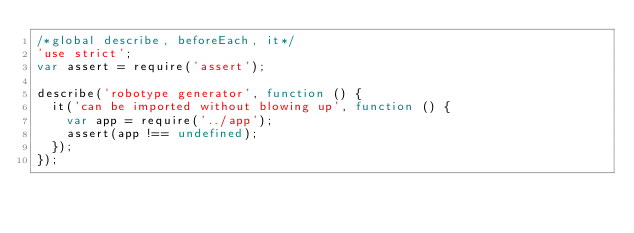Convert code to text. <code><loc_0><loc_0><loc_500><loc_500><_JavaScript_>/*global describe, beforeEach, it*/
'use strict';
var assert = require('assert');

describe('robotype generator', function () {
  it('can be imported without blowing up', function () {
    var app = require('../app');
    assert(app !== undefined);
  });
});
</code> 